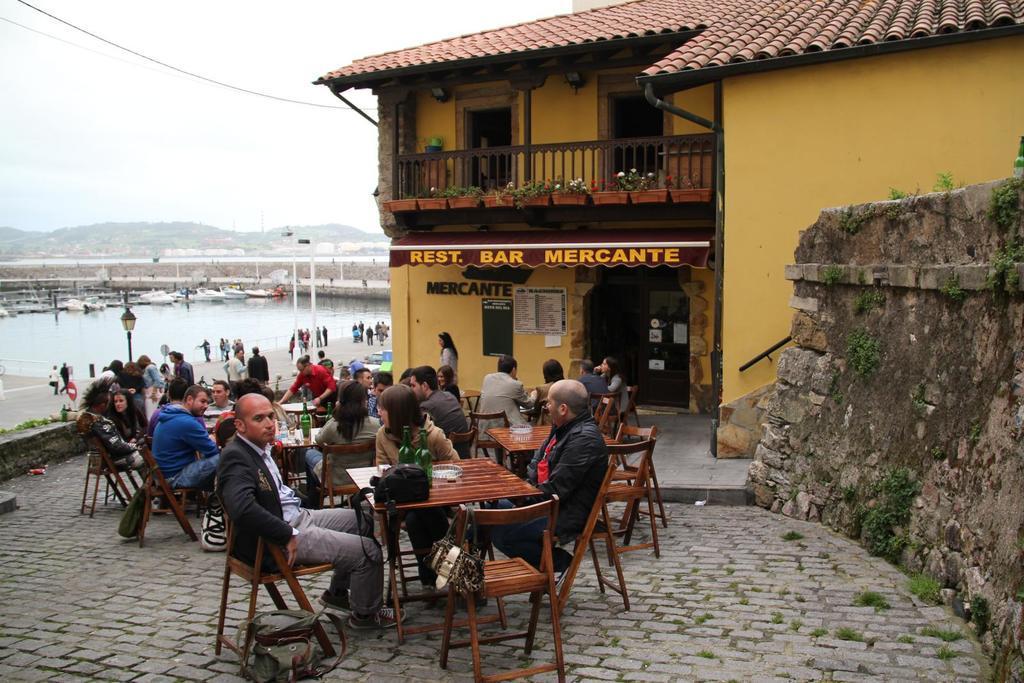Describe this image in one or two sentences. This picture is taken outside the restaurant in which there are people sitting around the table. On the table there is wine bottle,glass and a bag. At the background there are people who are standing near the water. At the top there are hills and sky. 